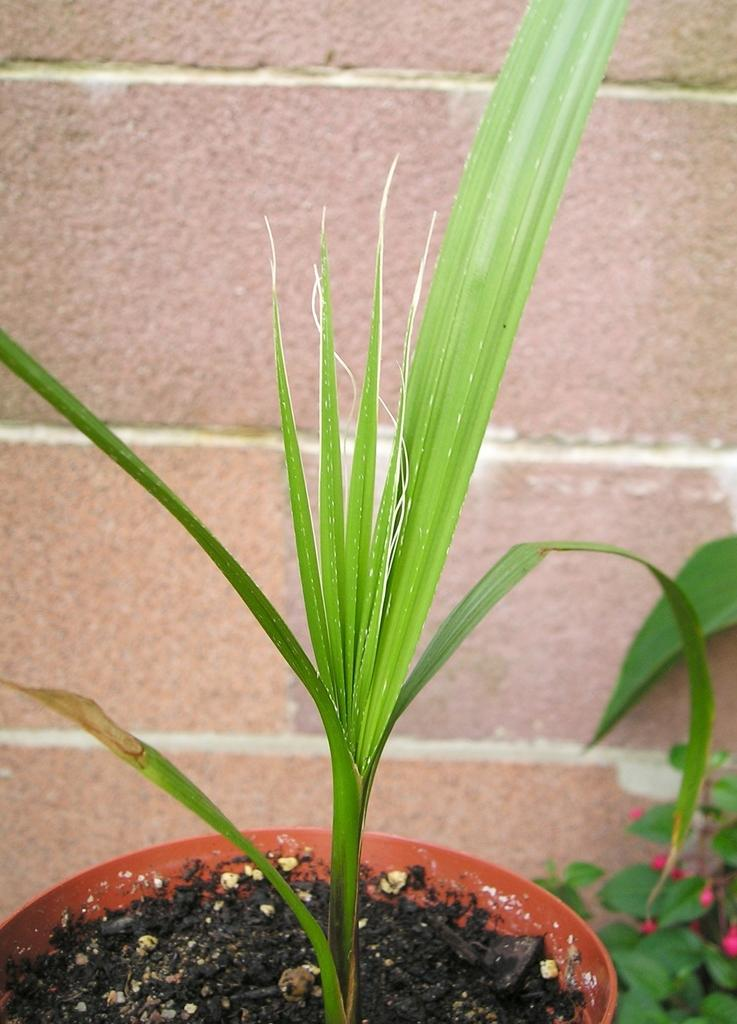What type of plant can be seen in the image? There is a potted plant in the image. What is visible in the background of the image? There is a wall in the background of the image. Are there any other plants in the image besides the potted plant? Yes, there is another plant on the right side of the image. What type of blade can be seen cutting through the plant in the image? There is no blade cutting through any plant in the image. 